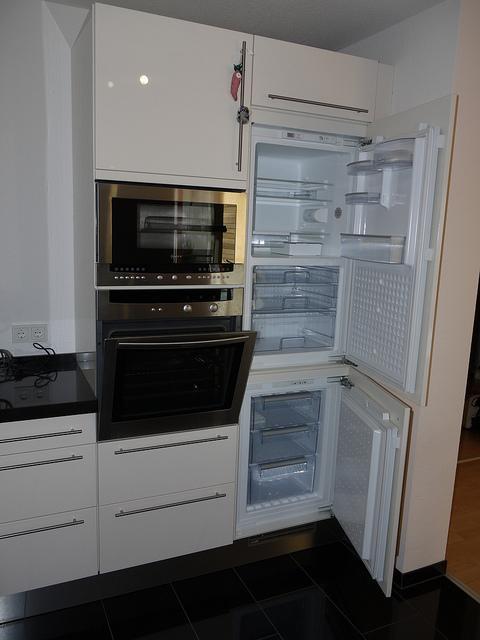The kitchen adheres to the electrical standards set in which region?
Choose the correct response and explain in the format: 'Answer: answer
Rationale: rationale.'
Options: Australia, north america, europe, south america. Answer: europe.
Rationale: The plugins look like they are european. 